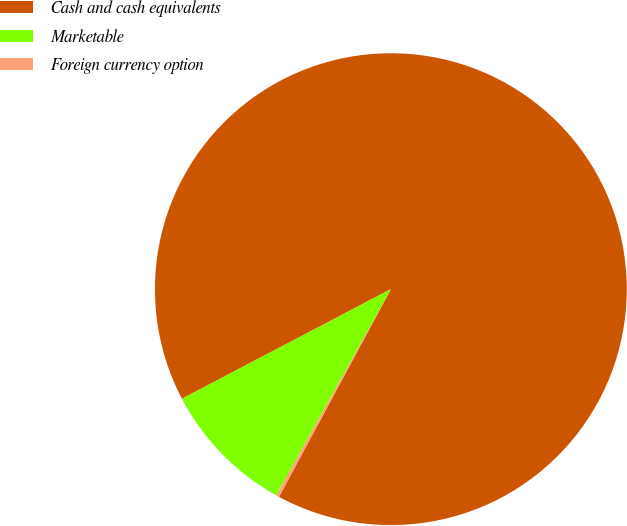<chart> <loc_0><loc_0><loc_500><loc_500><pie_chart><fcel>Cash and cash equivalents<fcel>Marketable<fcel>Foreign currency option<nl><fcel>90.55%<fcel>9.24%<fcel>0.21%<nl></chart> 